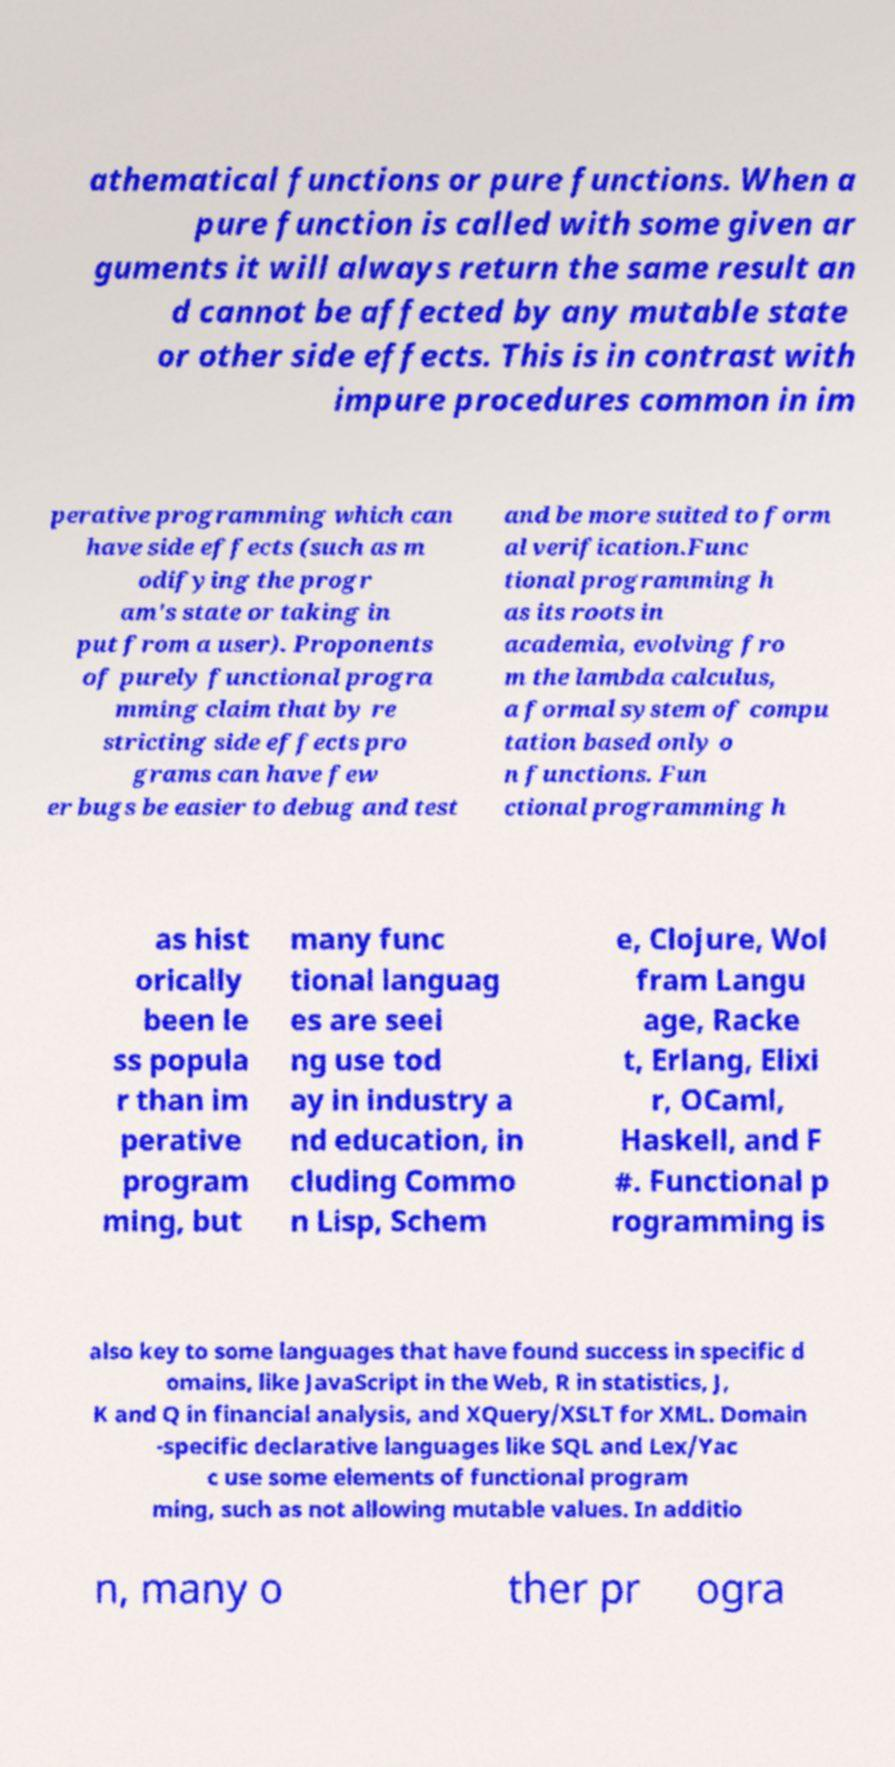What messages or text are displayed in this image? I need them in a readable, typed format. athematical functions or pure functions. When a pure function is called with some given ar guments it will always return the same result an d cannot be affected by any mutable state or other side effects. This is in contrast with impure procedures common in im perative programming which can have side effects (such as m odifying the progr am's state or taking in put from a user). Proponents of purely functional progra mming claim that by re stricting side effects pro grams can have few er bugs be easier to debug and test and be more suited to form al verification.Func tional programming h as its roots in academia, evolving fro m the lambda calculus, a formal system of compu tation based only o n functions. Fun ctional programming h as hist orically been le ss popula r than im perative program ming, but many func tional languag es are seei ng use tod ay in industry a nd education, in cluding Commo n Lisp, Schem e, Clojure, Wol fram Langu age, Racke t, Erlang, Elixi r, OCaml, Haskell, and F #. Functional p rogramming is also key to some languages that have found success in specific d omains, like JavaScript in the Web, R in statistics, J, K and Q in financial analysis, and XQuery/XSLT for XML. Domain -specific declarative languages like SQL and Lex/Yac c use some elements of functional program ming, such as not allowing mutable values. In additio n, many o ther pr ogra 